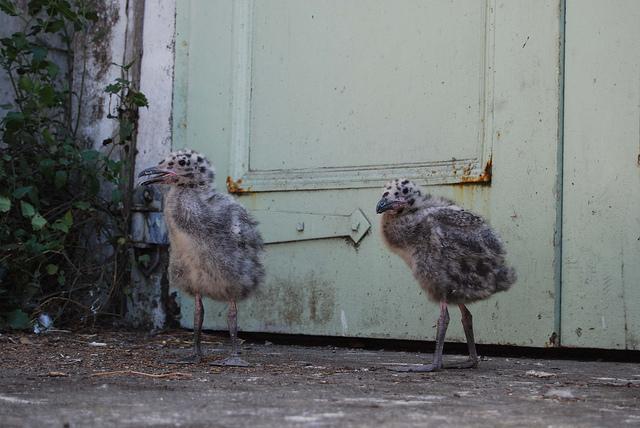How many birds are there?
Give a very brief answer. 2. 